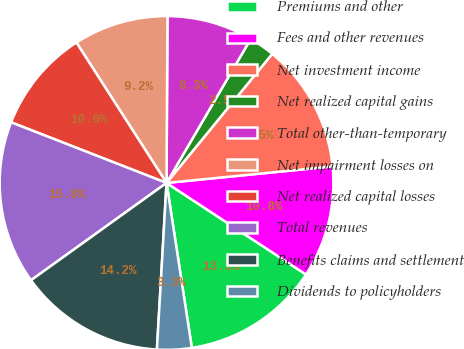<chart> <loc_0><loc_0><loc_500><loc_500><pie_chart><fcel>Premiums and other<fcel>Fees and other revenues<fcel>Net investment income<fcel>Net realized capital gains<fcel>Total other-than-temporary<fcel>Net impairment losses on<fcel>Net realized capital losses<fcel>Total revenues<fcel>Benefits claims and settlement<fcel>Dividends to policyholders<nl><fcel>13.33%<fcel>10.83%<fcel>12.5%<fcel>2.5%<fcel>8.33%<fcel>9.17%<fcel>10.0%<fcel>15.83%<fcel>14.17%<fcel>3.34%<nl></chart> 